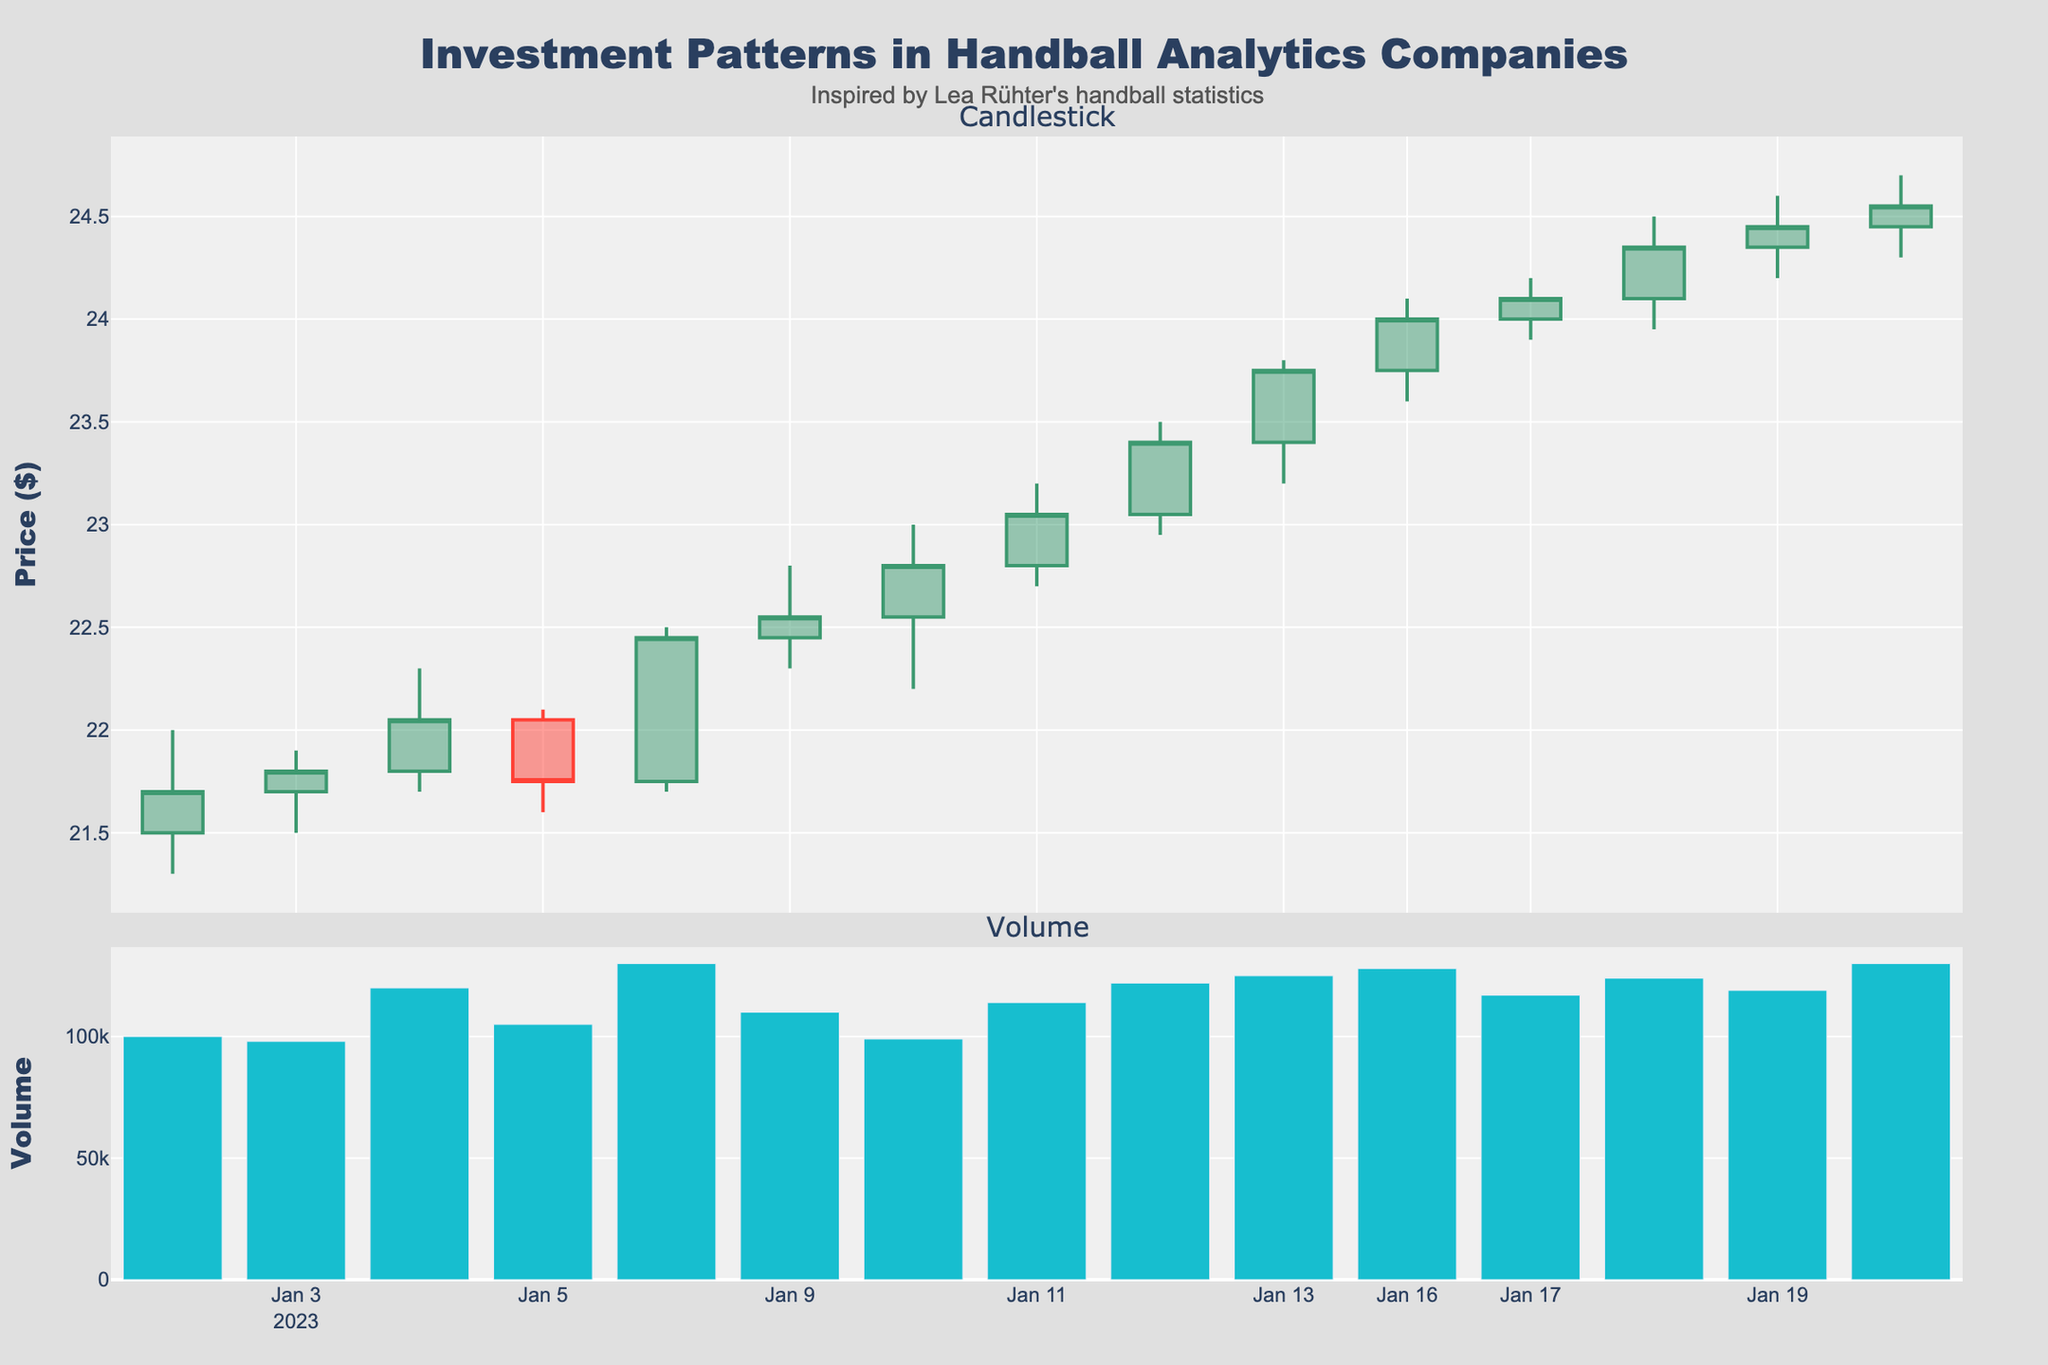Are there any annotations on the plot? Yes, there's an annotation at the top reading "Inspired by Lea Rühter's handball statistics."
Answer: Yes What is the title of the figure? The title is positioned at the top center of the plot and reads, "Investment Patterns in Handball Analytics Companies."
Answer: Investment Patterns in Handball Analytics Companies What is the highest closing price within the date range shown? The highest closing price can be found on January 20th, 2023, where the closing price was $24.55.
Answer: $24.55 How does the volume on January 13 compare to January 10? By comparing the two bars in the volume subplot, you can see that January 13 has a higher volume than January 10.
Answer: January 13 has a higher volume Which day had the largest spread (difference between high and low prices)? The largest spread can be calculated by subtracting the low price from the high price for each day. January 6th, 2023, with a spread of $0.80 ($22.50 - $21.70), has the largest spread.
Answer: January 6, 2023 How does the closing price on January 4 compare to its opening price? The closing price on January 4th was $22.05, while the opening price was $21.80. The closing price is higher than the opening price by $0.25.
Answer: Higher by $0.25 What is the average closing price over the entire period? Sum all the closing prices together and divide by the number of days. Calculation: (21.70 + 21.80 + 22.05 + 21.75 + 22.45 + 22.55 + 22.80 + 23.05 + 23.40 + 23.75 + 24.00 + 24.10 + 24.35 + 24.45 + 24.55) / 14 = 22.93
Answer: 22.93 Which day had the largest trading volume, and what was the value? The largest trading volume can be identified by looking at the volume subplot. January 20th, 2023, has the largest volume with 130,000 shares traded.
Answer: January 20, 2023, with a volume of 130,000 Did the stock price have more days of increase or decrease? By observing the candlestick colors, we identify the days with green (increase) and red (decrease). There are more green candles than red.
Answer: More days of increase What is the trend in closing prices from January 12 to January 16? The closing prices from January 12 to January 16 show an increasing trend, moving from $23.40 to $24.00.
Answer: Increasing 